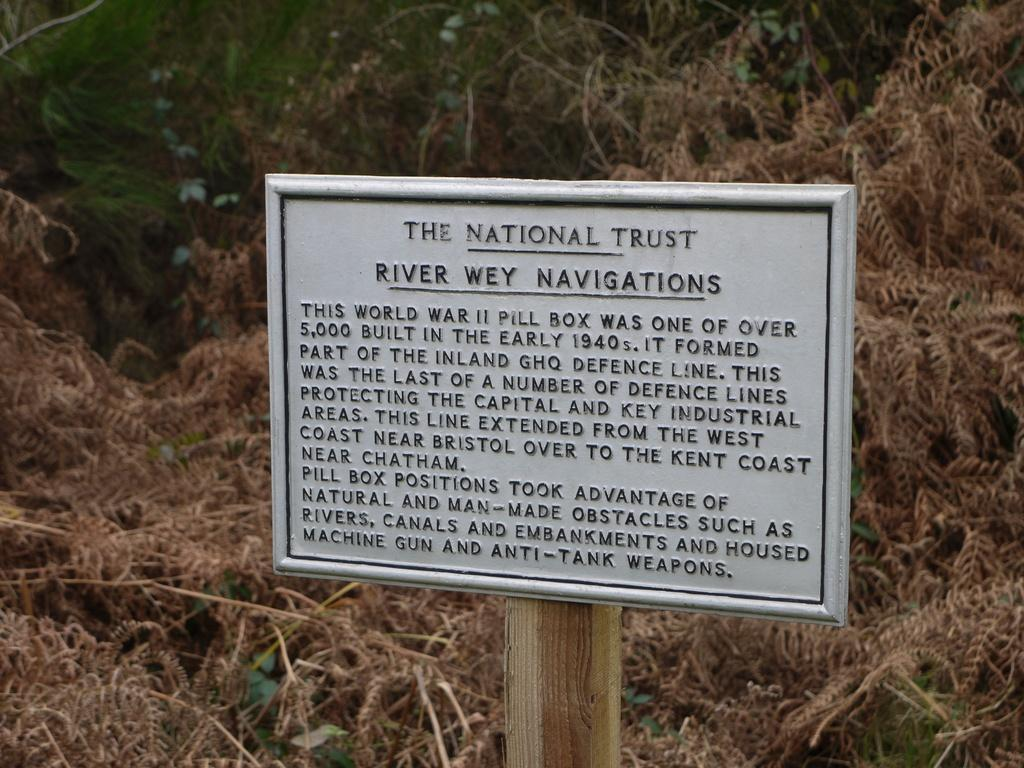What is the main object in the image? There is a board in the image. How is the board supported or connected to another object? The board is attached to a wooden pole. What can be found on the board? There is information mentioned on the board. What is the background of the image like? There are many dry plants behind the board. What type of engine is powering the board in the image? There is no engine present in the image; the board is stationary and attached to a wooden pole. 